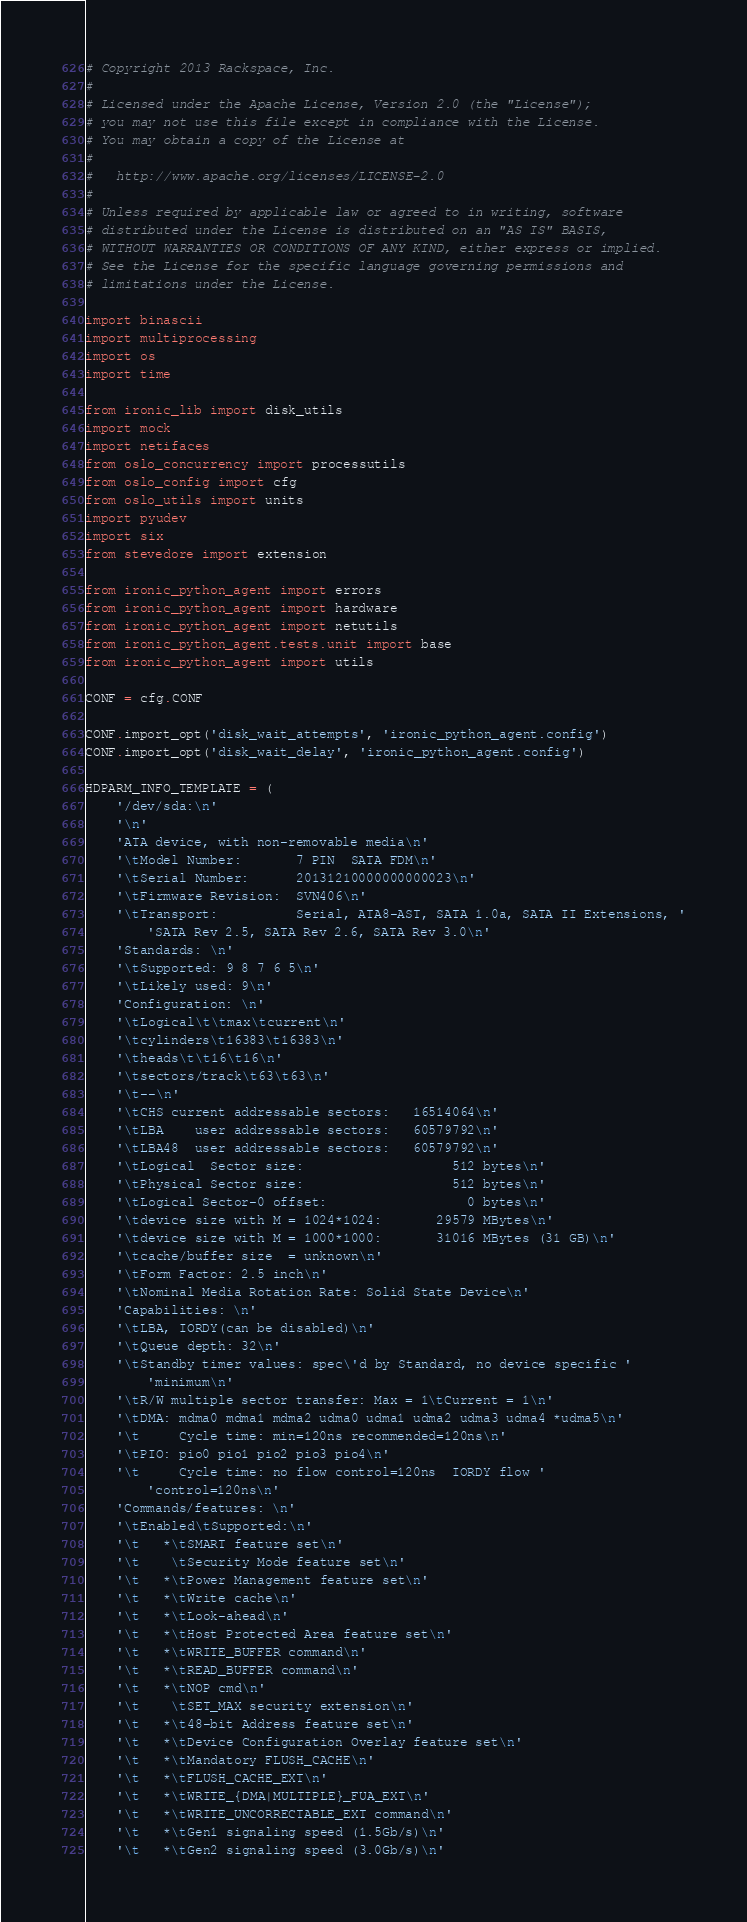<code> <loc_0><loc_0><loc_500><loc_500><_Python_># Copyright 2013 Rackspace, Inc.
#
# Licensed under the Apache License, Version 2.0 (the "License");
# you may not use this file except in compliance with the License.
# You may obtain a copy of the License at
#
#   http://www.apache.org/licenses/LICENSE-2.0
#
# Unless required by applicable law or agreed to in writing, software
# distributed under the License is distributed on an "AS IS" BASIS,
# WITHOUT WARRANTIES OR CONDITIONS OF ANY KIND, either express or implied.
# See the License for the specific language governing permissions and
# limitations under the License.

import binascii
import multiprocessing
import os
import time

from ironic_lib import disk_utils
import mock
import netifaces
from oslo_concurrency import processutils
from oslo_config import cfg
from oslo_utils import units
import pyudev
import six
from stevedore import extension

from ironic_python_agent import errors
from ironic_python_agent import hardware
from ironic_python_agent import netutils
from ironic_python_agent.tests.unit import base
from ironic_python_agent import utils

CONF = cfg.CONF

CONF.import_opt('disk_wait_attempts', 'ironic_python_agent.config')
CONF.import_opt('disk_wait_delay', 'ironic_python_agent.config')

HDPARM_INFO_TEMPLATE = (
    '/dev/sda:\n'
    '\n'
    'ATA device, with non-removable media\n'
    '\tModel Number:       7 PIN  SATA FDM\n'
    '\tSerial Number:      20131210000000000023\n'
    '\tFirmware Revision:  SVN406\n'
    '\tTransport:          Serial, ATA8-AST, SATA 1.0a, SATA II Extensions, '
        'SATA Rev 2.5, SATA Rev 2.6, SATA Rev 3.0\n'
    'Standards: \n'
    '\tSupported: 9 8 7 6 5\n'
    '\tLikely used: 9\n'
    'Configuration: \n'
    '\tLogical\t\tmax\tcurrent\n'
    '\tcylinders\t16383\t16383\n'
    '\theads\t\t16\t16\n'
    '\tsectors/track\t63\t63\n'
    '\t--\n'
    '\tCHS current addressable sectors:   16514064\n'
    '\tLBA    user addressable sectors:   60579792\n'
    '\tLBA48  user addressable sectors:   60579792\n'
    '\tLogical  Sector size:                   512 bytes\n'
    '\tPhysical Sector size:                   512 bytes\n'
    '\tLogical Sector-0 offset:                  0 bytes\n'
    '\tdevice size with M = 1024*1024:       29579 MBytes\n'
    '\tdevice size with M = 1000*1000:       31016 MBytes (31 GB)\n'
    '\tcache/buffer size  = unknown\n'
    '\tForm Factor: 2.5 inch\n'
    '\tNominal Media Rotation Rate: Solid State Device\n'
    'Capabilities: \n'
    '\tLBA, IORDY(can be disabled)\n'
    '\tQueue depth: 32\n'
    '\tStandby timer values: spec\'d by Standard, no device specific '
        'minimum\n'
    '\tR/W multiple sector transfer: Max = 1\tCurrent = 1\n'
    '\tDMA: mdma0 mdma1 mdma2 udma0 udma1 udma2 udma3 udma4 *udma5\n'
    '\t     Cycle time: min=120ns recommended=120ns\n'
    '\tPIO: pio0 pio1 pio2 pio3 pio4\n'
    '\t     Cycle time: no flow control=120ns  IORDY flow '
        'control=120ns\n'
    'Commands/features: \n'
    '\tEnabled\tSupported:\n'
    '\t   *\tSMART feature set\n'
    '\t    \tSecurity Mode feature set\n'
    '\t   *\tPower Management feature set\n'
    '\t   *\tWrite cache\n'
    '\t   *\tLook-ahead\n'
    '\t   *\tHost Protected Area feature set\n'
    '\t   *\tWRITE_BUFFER command\n'
    '\t   *\tREAD_BUFFER command\n'
    '\t   *\tNOP cmd\n'
    '\t    \tSET_MAX security extension\n'
    '\t   *\t48-bit Address feature set\n'
    '\t   *\tDevice Configuration Overlay feature set\n'
    '\t   *\tMandatory FLUSH_CACHE\n'
    '\t   *\tFLUSH_CACHE_EXT\n'
    '\t   *\tWRITE_{DMA|MULTIPLE}_FUA_EXT\n'
    '\t   *\tWRITE_UNCORRECTABLE_EXT command\n'
    '\t   *\tGen1 signaling speed (1.5Gb/s)\n'
    '\t   *\tGen2 signaling speed (3.0Gb/s)\n'</code> 